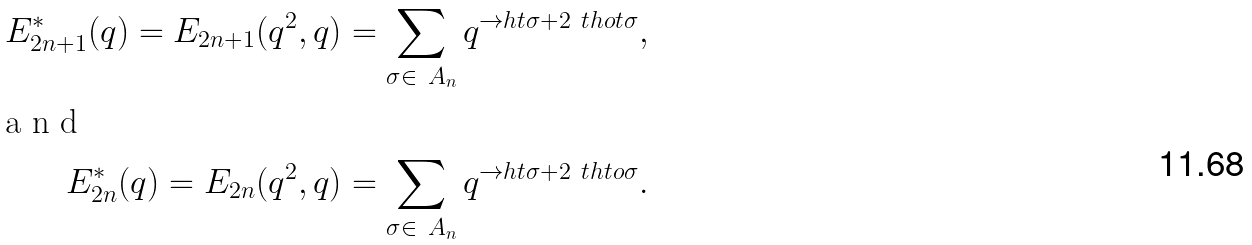<formula> <loc_0><loc_0><loc_500><loc_500>E _ { 2 n + 1 } ^ { * } ( q ) = E _ { 2 n + 1 } ( q ^ { 2 } , q ) = \sum _ { \sigma \in \ A _ { n } } q ^ { \to h t \sigma + 2 \ t h o t \sigma } , \intertext { a n d } E _ { 2 n } ^ { * } ( q ) = E _ { 2 n } ( q ^ { 2 } , q ) = \sum _ { \sigma \in \ A _ { n } } q ^ { \to h t \sigma + 2 \ t h t o \sigma } .</formula> 